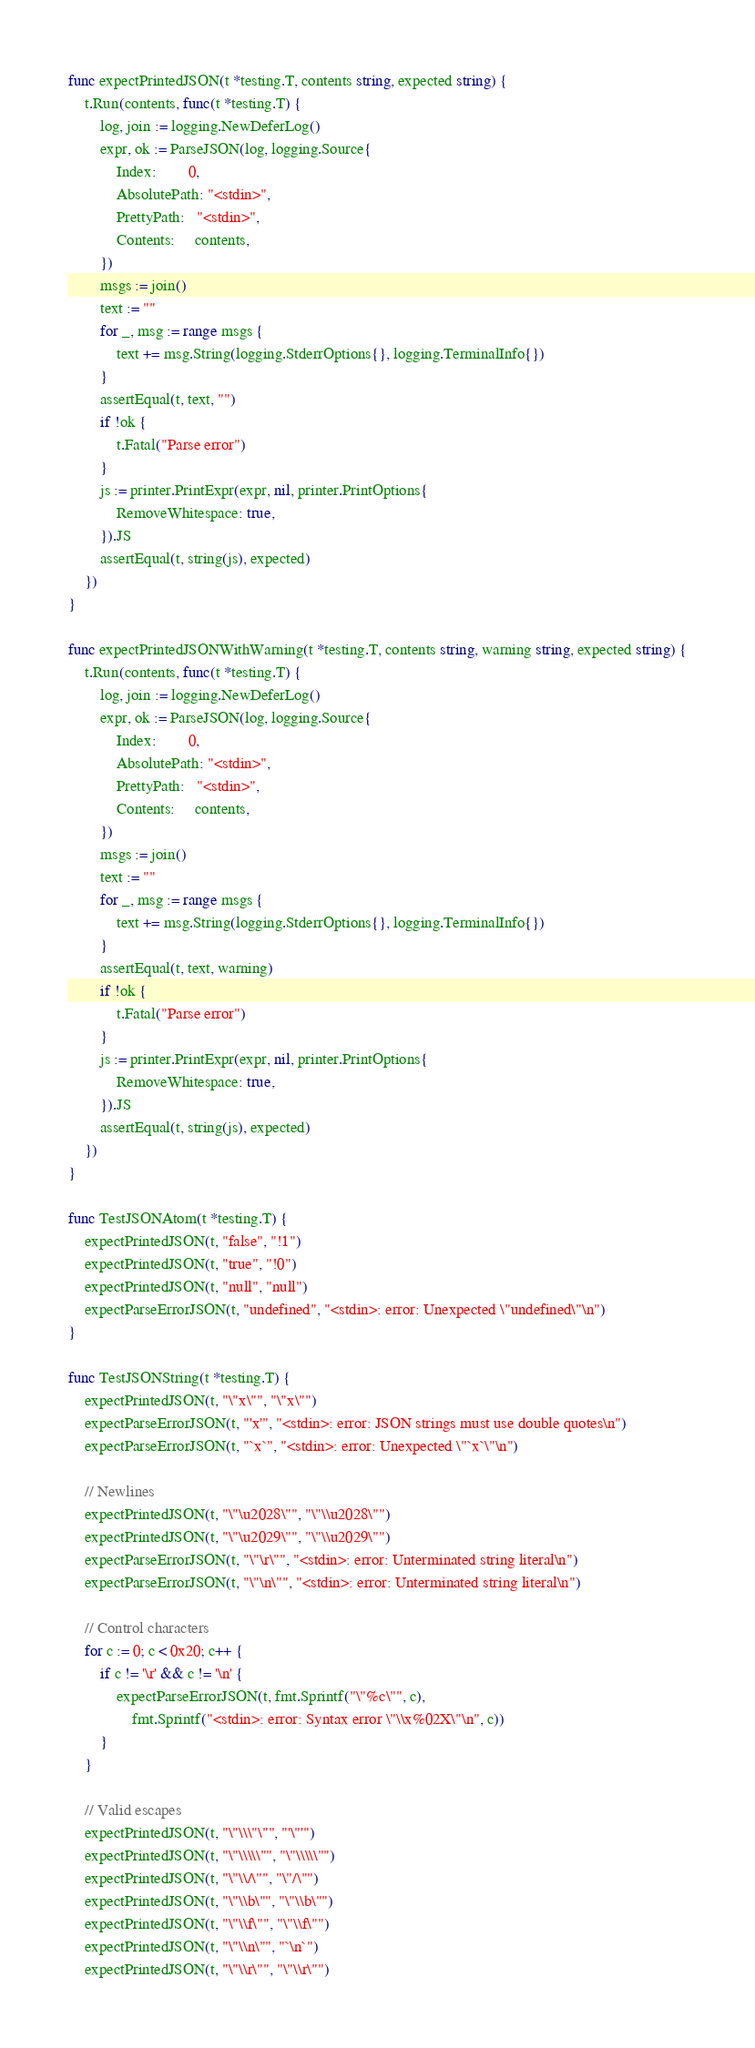<code> <loc_0><loc_0><loc_500><loc_500><_Go_>func expectPrintedJSON(t *testing.T, contents string, expected string) {
	t.Run(contents, func(t *testing.T) {
		log, join := logging.NewDeferLog()
		expr, ok := ParseJSON(log, logging.Source{
			Index:        0,
			AbsolutePath: "<stdin>",
			PrettyPath:   "<stdin>",
			Contents:     contents,
		})
		msgs := join()
		text := ""
		for _, msg := range msgs {
			text += msg.String(logging.StderrOptions{}, logging.TerminalInfo{})
		}
		assertEqual(t, text, "")
		if !ok {
			t.Fatal("Parse error")
		}
		js := printer.PrintExpr(expr, nil, printer.PrintOptions{
			RemoveWhitespace: true,
		}).JS
		assertEqual(t, string(js), expected)
	})
}

func expectPrintedJSONWithWarning(t *testing.T, contents string, warning string, expected string) {
	t.Run(contents, func(t *testing.T) {
		log, join := logging.NewDeferLog()
		expr, ok := ParseJSON(log, logging.Source{
			Index:        0,
			AbsolutePath: "<stdin>",
			PrettyPath:   "<stdin>",
			Contents:     contents,
		})
		msgs := join()
		text := ""
		for _, msg := range msgs {
			text += msg.String(logging.StderrOptions{}, logging.TerminalInfo{})
		}
		assertEqual(t, text, warning)
		if !ok {
			t.Fatal("Parse error")
		}
		js := printer.PrintExpr(expr, nil, printer.PrintOptions{
			RemoveWhitespace: true,
		}).JS
		assertEqual(t, string(js), expected)
	})
}

func TestJSONAtom(t *testing.T) {
	expectPrintedJSON(t, "false", "!1")
	expectPrintedJSON(t, "true", "!0")
	expectPrintedJSON(t, "null", "null")
	expectParseErrorJSON(t, "undefined", "<stdin>: error: Unexpected \"undefined\"\n")
}

func TestJSONString(t *testing.T) {
	expectPrintedJSON(t, "\"x\"", "\"x\"")
	expectParseErrorJSON(t, "'x'", "<stdin>: error: JSON strings must use double quotes\n")
	expectParseErrorJSON(t, "`x`", "<stdin>: error: Unexpected \"`x`\"\n")

	// Newlines
	expectPrintedJSON(t, "\"\u2028\"", "\"\\u2028\"")
	expectPrintedJSON(t, "\"\u2029\"", "\"\\u2029\"")
	expectParseErrorJSON(t, "\"\r\"", "<stdin>: error: Unterminated string literal\n")
	expectParseErrorJSON(t, "\"\n\"", "<stdin>: error: Unterminated string literal\n")

	// Control characters
	for c := 0; c < 0x20; c++ {
		if c != '\r' && c != '\n' {
			expectParseErrorJSON(t, fmt.Sprintf("\"%c\"", c),
				fmt.Sprintf("<stdin>: error: Syntax error \"\\x%02X\"\n", c))
		}
	}

	// Valid escapes
	expectPrintedJSON(t, "\"\\\"\"", "'\"'")
	expectPrintedJSON(t, "\"\\\\\"", "\"\\\\\"")
	expectPrintedJSON(t, "\"\\/\"", "\"/\"")
	expectPrintedJSON(t, "\"\\b\"", "\"\\b\"")
	expectPrintedJSON(t, "\"\\f\"", "\"\\f\"")
	expectPrintedJSON(t, "\"\\n\"", "`\n`")
	expectPrintedJSON(t, "\"\\r\"", "\"\\r\"")</code> 